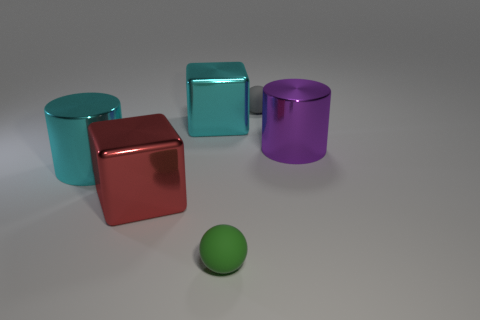Does the cyan metal object right of the red object have the same size as the large purple cylinder?
Make the answer very short. Yes. There is a cyan shiny cylinder; how many small gray rubber things are behind it?
Your answer should be very brief. 1. The thing that is behind the large purple cylinder and on the right side of the cyan block is made of what material?
Provide a short and direct response. Rubber. What number of large things are either gray rubber objects or red matte cylinders?
Provide a succinct answer. 0. The purple thing has what size?
Provide a short and direct response. Large. The big red metal object is what shape?
Your response must be concise. Cube. Is there anything else that is the same shape as the red thing?
Offer a very short reply. Yes. Is the number of small green matte things in front of the tiny green matte ball less than the number of cyan metallic things?
Offer a very short reply. Yes. What number of metal things are spheres or big purple cylinders?
Ensure brevity in your answer.  1. Is there anything else that has the same size as the purple cylinder?
Ensure brevity in your answer.  Yes. 